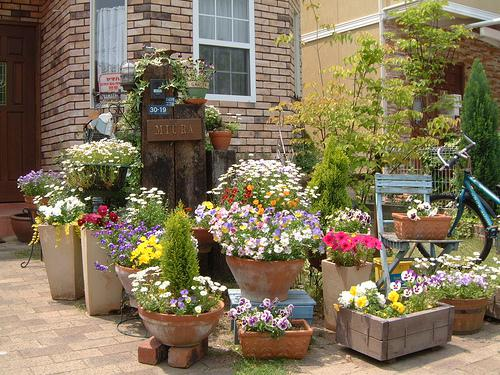Question: what color are the window sills?
Choices:
A. White.
B. Brown.
C. Black.
D. Red.
Answer with the letter. Answer: A Question: what word is written on the sign on the left?
Choices:
A. No parking.
B. Smith wedding.
C. One way.
D. Miura.
Answer with the letter. Answer: D 